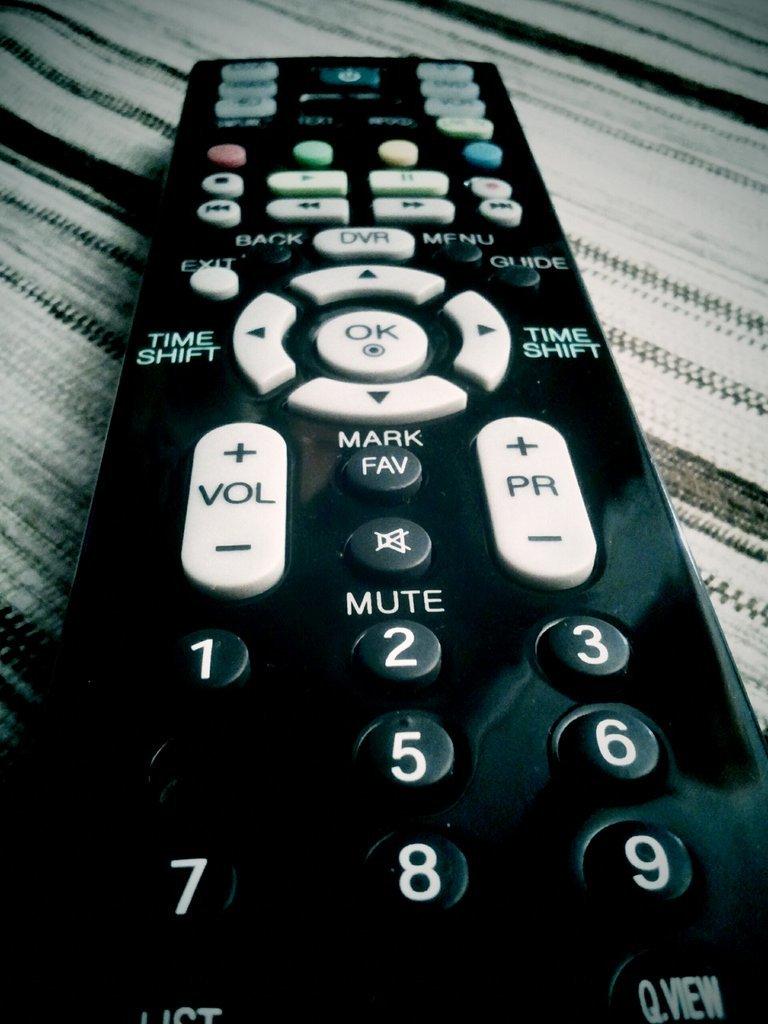What are you doing if you press the right arrow button?
Ensure brevity in your answer.  Time shift. 